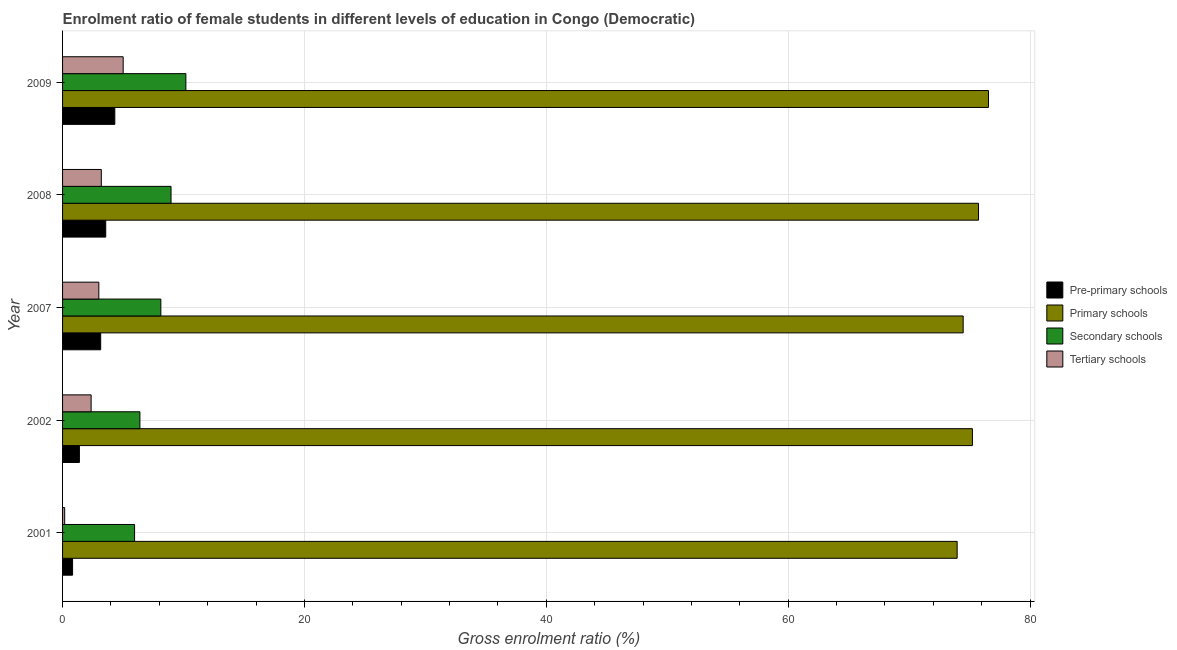How many different coloured bars are there?
Make the answer very short. 4. How many groups of bars are there?
Give a very brief answer. 5. How many bars are there on the 2nd tick from the bottom?
Provide a succinct answer. 4. What is the gross enrolment ratio(male) in pre-primary schools in 2002?
Your answer should be compact. 1.39. Across all years, what is the maximum gross enrolment ratio(male) in tertiary schools?
Ensure brevity in your answer.  5.01. Across all years, what is the minimum gross enrolment ratio(male) in tertiary schools?
Your answer should be very brief. 0.18. In which year was the gross enrolment ratio(male) in tertiary schools maximum?
Give a very brief answer. 2009. What is the total gross enrolment ratio(male) in secondary schools in the graph?
Make the answer very short. 39.64. What is the difference between the gross enrolment ratio(male) in secondary schools in 2002 and that in 2008?
Your answer should be very brief. -2.57. What is the difference between the gross enrolment ratio(male) in tertiary schools in 2002 and the gross enrolment ratio(male) in pre-primary schools in 2009?
Keep it short and to the point. -1.96. What is the average gross enrolment ratio(male) in pre-primary schools per year?
Provide a succinct answer. 2.65. In the year 2008, what is the difference between the gross enrolment ratio(male) in primary schools and gross enrolment ratio(male) in tertiary schools?
Offer a very short reply. 72.54. In how many years, is the gross enrolment ratio(male) in primary schools greater than 20 %?
Your response must be concise. 5. What is the ratio of the gross enrolment ratio(male) in secondary schools in 2008 to that in 2009?
Your answer should be very brief. 0.88. What is the difference between the highest and the second highest gross enrolment ratio(male) in pre-primary schools?
Your answer should be very brief. 0.75. What is the difference between the highest and the lowest gross enrolment ratio(male) in secondary schools?
Ensure brevity in your answer.  4.24. In how many years, is the gross enrolment ratio(male) in primary schools greater than the average gross enrolment ratio(male) in primary schools taken over all years?
Ensure brevity in your answer.  3. Is the sum of the gross enrolment ratio(male) in tertiary schools in 2001 and 2009 greater than the maximum gross enrolment ratio(male) in secondary schools across all years?
Offer a terse response. No. What does the 2nd bar from the top in 2007 represents?
Provide a succinct answer. Secondary schools. What does the 2nd bar from the bottom in 2007 represents?
Your answer should be compact. Primary schools. How many bars are there?
Offer a very short reply. 20. What is the difference between two consecutive major ticks on the X-axis?
Provide a succinct answer. 20. Does the graph contain grids?
Ensure brevity in your answer.  Yes. Where does the legend appear in the graph?
Provide a succinct answer. Center right. What is the title of the graph?
Give a very brief answer. Enrolment ratio of female students in different levels of education in Congo (Democratic). Does "HFC gas" appear as one of the legend labels in the graph?
Provide a succinct answer. No. What is the label or title of the X-axis?
Give a very brief answer. Gross enrolment ratio (%). What is the label or title of the Y-axis?
Your response must be concise. Year. What is the Gross enrolment ratio (%) of Pre-primary schools in 2001?
Keep it short and to the point. 0.83. What is the Gross enrolment ratio (%) of Primary schools in 2001?
Keep it short and to the point. 73.98. What is the Gross enrolment ratio (%) of Secondary schools in 2001?
Offer a very short reply. 5.95. What is the Gross enrolment ratio (%) in Tertiary schools in 2001?
Provide a short and direct response. 0.18. What is the Gross enrolment ratio (%) in Pre-primary schools in 2002?
Make the answer very short. 1.39. What is the Gross enrolment ratio (%) in Primary schools in 2002?
Offer a very short reply. 75.24. What is the Gross enrolment ratio (%) in Secondary schools in 2002?
Make the answer very short. 6.4. What is the Gross enrolment ratio (%) in Tertiary schools in 2002?
Provide a succinct answer. 2.36. What is the Gross enrolment ratio (%) of Pre-primary schools in 2007?
Your response must be concise. 3.15. What is the Gross enrolment ratio (%) of Primary schools in 2007?
Provide a succinct answer. 74.47. What is the Gross enrolment ratio (%) of Secondary schools in 2007?
Keep it short and to the point. 8.13. What is the Gross enrolment ratio (%) in Tertiary schools in 2007?
Ensure brevity in your answer.  3. What is the Gross enrolment ratio (%) of Pre-primary schools in 2008?
Provide a succinct answer. 3.57. What is the Gross enrolment ratio (%) in Primary schools in 2008?
Your response must be concise. 75.74. What is the Gross enrolment ratio (%) in Secondary schools in 2008?
Your response must be concise. 8.97. What is the Gross enrolment ratio (%) in Tertiary schools in 2008?
Give a very brief answer. 3.2. What is the Gross enrolment ratio (%) of Pre-primary schools in 2009?
Give a very brief answer. 4.32. What is the Gross enrolment ratio (%) in Primary schools in 2009?
Your response must be concise. 76.57. What is the Gross enrolment ratio (%) in Secondary schools in 2009?
Give a very brief answer. 10.2. What is the Gross enrolment ratio (%) of Tertiary schools in 2009?
Your answer should be compact. 5.01. Across all years, what is the maximum Gross enrolment ratio (%) of Pre-primary schools?
Keep it short and to the point. 4.32. Across all years, what is the maximum Gross enrolment ratio (%) in Primary schools?
Give a very brief answer. 76.57. Across all years, what is the maximum Gross enrolment ratio (%) of Secondary schools?
Your answer should be very brief. 10.2. Across all years, what is the maximum Gross enrolment ratio (%) of Tertiary schools?
Your answer should be very brief. 5.01. Across all years, what is the minimum Gross enrolment ratio (%) of Pre-primary schools?
Offer a very short reply. 0.83. Across all years, what is the minimum Gross enrolment ratio (%) of Primary schools?
Your answer should be very brief. 73.98. Across all years, what is the minimum Gross enrolment ratio (%) of Secondary schools?
Provide a short and direct response. 5.95. Across all years, what is the minimum Gross enrolment ratio (%) in Tertiary schools?
Offer a terse response. 0.18. What is the total Gross enrolment ratio (%) in Pre-primary schools in the graph?
Offer a very short reply. 13.26. What is the total Gross enrolment ratio (%) in Primary schools in the graph?
Offer a terse response. 376. What is the total Gross enrolment ratio (%) of Secondary schools in the graph?
Keep it short and to the point. 39.64. What is the total Gross enrolment ratio (%) in Tertiary schools in the graph?
Make the answer very short. 13.75. What is the difference between the Gross enrolment ratio (%) in Pre-primary schools in 2001 and that in 2002?
Offer a terse response. -0.56. What is the difference between the Gross enrolment ratio (%) in Primary schools in 2001 and that in 2002?
Ensure brevity in your answer.  -1.26. What is the difference between the Gross enrolment ratio (%) of Secondary schools in 2001 and that in 2002?
Your answer should be very brief. -0.44. What is the difference between the Gross enrolment ratio (%) of Tertiary schools in 2001 and that in 2002?
Ensure brevity in your answer.  -2.19. What is the difference between the Gross enrolment ratio (%) of Pre-primary schools in 2001 and that in 2007?
Provide a succinct answer. -2.32. What is the difference between the Gross enrolment ratio (%) of Primary schools in 2001 and that in 2007?
Ensure brevity in your answer.  -0.5. What is the difference between the Gross enrolment ratio (%) of Secondary schools in 2001 and that in 2007?
Ensure brevity in your answer.  -2.17. What is the difference between the Gross enrolment ratio (%) in Tertiary schools in 2001 and that in 2007?
Keep it short and to the point. -2.82. What is the difference between the Gross enrolment ratio (%) of Pre-primary schools in 2001 and that in 2008?
Your answer should be very brief. -2.74. What is the difference between the Gross enrolment ratio (%) in Primary schools in 2001 and that in 2008?
Provide a short and direct response. -1.77. What is the difference between the Gross enrolment ratio (%) in Secondary schools in 2001 and that in 2008?
Make the answer very short. -3.01. What is the difference between the Gross enrolment ratio (%) of Tertiary schools in 2001 and that in 2008?
Ensure brevity in your answer.  -3.03. What is the difference between the Gross enrolment ratio (%) in Pre-primary schools in 2001 and that in 2009?
Your answer should be compact. -3.49. What is the difference between the Gross enrolment ratio (%) in Primary schools in 2001 and that in 2009?
Keep it short and to the point. -2.59. What is the difference between the Gross enrolment ratio (%) in Secondary schools in 2001 and that in 2009?
Give a very brief answer. -4.24. What is the difference between the Gross enrolment ratio (%) in Tertiary schools in 2001 and that in 2009?
Your answer should be compact. -4.84. What is the difference between the Gross enrolment ratio (%) of Pre-primary schools in 2002 and that in 2007?
Your response must be concise. -1.76. What is the difference between the Gross enrolment ratio (%) in Primary schools in 2002 and that in 2007?
Ensure brevity in your answer.  0.76. What is the difference between the Gross enrolment ratio (%) of Secondary schools in 2002 and that in 2007?
Your response must be concise. -1.73. What is the difference between the Gross enrolment ratio (%) of Tertiary schools in 2002 and that in 2007?
Provide a short and direct response. -0.64. What is the difference between the Gross enrolment ratio (%) of Pre-primary schools in 2002 and that in 2008?
Provide a succinct answer. -2.18. What is the difference between the Gross enrolment ratio (%) of Primary schools in 2002 and that in 2008?
Provide a short and direct response. -0.5. What is the difference between the Gross enrolment ratio (%) in Secondary schools in 2002 and that in 2008?
Offer a terse response. -2.57. What is the difference between the Gross enrolment ratio (%) of Tertiary schools in 2002 and that in 2008?
Provide a succinct answer. -0.84. What is the difference between the Gross enrolment ratio (%) of Pre-primary schools in 2002 and that in 2009?
Make the answer very short. -2.93. What is the difference between the Gross enrolment ratio (%) in Primary schools in 2002 and that in 2009?
Offer a very short reply. -1.33. What is the difference between the Gross enrolment ratio (%) of Secondary schools in 2002 and that in 2009?
Ensure brevity in your answer.  -3.8. What is the difference between the Gross enrolment ratio (%) of Tertiary schools in 2002 and that in 2009?
Your response must be concise. -2.65. What is the difference between the Gross enrolment ratio (%) in Pre-primary schools in 2007 and that in 2008?
Your response must be concise. -0.42. What is the difference between the Gross enrolment ratio (%) in Primary schools in 2007 and that in 2008?
Your response must be concise. -1.27. What is the difference between the Gross enrolment ratio (%) in Secondary schools in 2007 and that in 2008?
Make the answer very short. -0.84. What is the difference between the Gross enrolment ratio (%) of Tertiary schools in 2007 and that in 2008?
Give a very brief answer. -0.21. What is the difference between the Gross enrolment ratio (%) in Pre-primary schools in 2007 and that in 2009?
Provide a succinct answer. -1.17. What is the difference between the Gross enrolment ratio (%) in Primary schools in 2007 and that in 2009?
Provide a succinct answer. -2.09. What is the difference between the Gross enrolment ratio (%) of Secondary schools in 2007 and that in 2009?
Ensure brevity in your answer.  -2.07. What is the difference between the Gross enrolment ratio (%) of Tertiary schools in 2007 and that in 2009?
Your response must be concise. -2.01. What is the difference between the Gross enrolment ratio (%) in Pre-primary schools in 2008 and that in 2009?
Your answer should be very brief. -0.75. What is the difference between the Gross enrolment ratio (%) of Primary schools in 2008 and that in 2009?
Your answer should be compact. -0.83. What is the difference between the Gross enrolment ratio (%) of Secondary schools in 2008 and that in 2009?
Your answer should be compact. -1.23. What is the difference between the Gross enrolment ratio (%) in Tertiary schools in 2008 and that in 2009?
Provide a short and direct response. -1.81. What is the difference between the Gross enrolment ratio (%) of Pre-primary schools in 2001 and the Gross enrolment ratio (%) of Primary schools in 2002?
Make the answer very short. -74.41. What is the difference between the Gross enrolment ratio (%) of Pre-primary schools in 2001 and the Gross enrolment ratio (%) of Secondary schools in 2002?
Keep it short and to the point. -5.57. What is the difference between the Gross enrolment ratio (%) of Pre-primary schools in 2001 and the Gross enrolment ratio (%) of Tertiary schools in 2002?
Offer a terse response. -1.53. What is the difference between the Gross enrolment ratio (%) in Primary schools in 2001 and the Gross enrolment ratio (%) in Secondary schools in 2002?
Offer a very short reply. 67.58. What is the difference between the Gross enrolment ratio (%) of Primary schools in 2001 and the Gross enrolment ratio (%) of Tertiary schools in 2002?
Your answer should be very brief. 71.61. What is the difference between the Gross enrolment ratio (%) in Secondary schools in 2001 and the Gross enrolment ratio (%) in Tertiary schools in 2002?
Make the answer very short. 3.59. What is the difference between the Gross enrolment ratio (%) in Pre-primary schools in 2001 and the Gross enrolment ratio (%) in Primary schools in 2007?
Provide a succinct answer. -73.65. What is the difference between the Gross enrolment ratio (%) of Pre-primary schools in 2001 and the Gross enrolment ratio (%) of Secondary schools in 2007?
Keep it short and to the point. -7.3. What is the difference between the Gross enrolment ratio (%) in Pre-primary schools in 2001 and the Gross enrolment ratio (%) in Tertiary schools in 2007?
Offer a very short reply. -2.17. What is the difference between the Gross enrolment ratio (%) of Primary schools in 2001 and the Gross enrolment ratio (%) of Secondary schools in 2007?
Ensure brevity in your answer.  65.85. What is the difference between the Gross enrolment ratio (%) of Primary schools in 2001 and the Gross enrolment ratio (%) of Tertiary schools in 2007?
Provide a short and direct response. 70.98. What is the difference between the Gross enrolment ratio (%) in Secondary schools in 2001 and the Gross enrolment ratio (%) in Tertiary schools in 2007?
Make the answer very short. 2.96. What is the difference between the Gross enrolment ratio (%) of Pre-primary schools in 2001 and the Gross enrolment ratio (%) of Primary schools in 2008?
Your answer should be very brief. -74.91. What is the difference between the Gross enrolment ratio (%) in Pre-primary schools in 2001 and the Gross enrolment ratio (%) in Secondary schools in 2008?
Your answer should be compact. -8.14. What is the difference between the Gross enrolment ratio (%) in Pre-primary schools in 2001 and the Gross enrolment ratio (%) in Tertiary schools in 2008?
Offer a terse response. -2.38. What is the difference between the Gross enrolment ratio (%) of Primary schools in 2001 and the Gross enrolment ratio (%) of Secondary schools in 2008?
Your answer should be very brief. 65.01. What is the difference between the Gross enrolment ratio (%) in Primary schools in 2001 and the Gross enrolment ratio (%) in Tertiary schools in 2008?
Your answer should be compact. 70.77. What is the difference between the Gross enrolment ratio (%) in Secondary schools in 2001 and the Gross enrolment ratio (%) in Tertiary schools in 2008?
Keep it short and to the point. 2.75. What is the difference between the Gross enrolment ratio (%) of Pre-primary schools in 2001 and the Gross enrolment ratio (%) of Primary schools in 2009?
Make the answer very short. -75.74. What is the difference between the Gross enrolment ratio (%) of Pre-primary schools in 2001 and the Gross enrolment ratio (%) of Secondary schools in 2009?
Your answer should be compact. -9.37. What is the difference between the Gross enrolment ratio (%) in Pre-primary schools in 2001 and the Gross enrolment ratio (%) in Tertiary schools in 2009?
Provide a succinct answer. -4.18. What is the difference between the Gross enrolment ratio (%) in Primary schools in 2001 and the Gross enrolment ratio (%) in Secondary schools in 2009?
Provide a succinct answer. 63.78. What is the difference between the Gross enrolment ratio (%) in Primary schools in 2001 and the Gross enrolment ratio (%) in Tertiary schools in 2009?
Ensure brevity in your answer.  68.96. What is the difference between the Gross enrolment ratio (%) of Secondary schools in 2001 and the Gross enrolment ratio (%) of Tertiary schools in 2009?
Provide a short and direct response. 0.94. What is the difference between the Gross enrolment ratio (%) of Pre-primary schools in 2002 and the Gross enrolment ratio (%) of Primary schools in 2007?
Ensure brevity in your answer.  -73.08. What is the difference between the Gross enrolment ratio (%) in Pre-primary schools in 2002 and the Gross enrolment ratio (%) in Secondary schools in 2007?
Keep it short and to the point. -6.73. What is the difference between the Gross enrolment ratio (%) of Pre-primary schools in 2002 and the Gross enrolment ratio (%) of Tertiary schools in 2007?
Your answer should be very brief. -1.61. What is the difference between the Gross enrolment ratio (%) in Primary schools in 2002 and the Gross enrolment ratio (%) in Secondary schools in 2007?
Offer a very short reply. 67.11. What is the difference between the Gross enrolment ratio (%) of Primary schools in 2002 and the Gross enrolment ratio (%) of Tertiary schools in 2007?
Provide a short and direct response. 72.24. What is the difference between the Gross enrolment ratio (%) in Secondary schools in 2002 and the Gross enrolment ratio (%) in Tertiary schools in 2007?
Keep it short and to the point. 3.4. What is the difference between the Gross enrolment ratio (%) in Pre-primary schools in 2002 and the Gross enrolment ratio (%) in Primary schools in 2008?
Give a very brief answer. -74.35. What is the difference between the Gross enrolment ratio (%) of Pre-primary schools in 2002 and the Gross enrolment ratio (%) of Secondary schools in 2008?
Offer a terse response. -7.58. What is the difference between the Gross enrolment ratio (%) in Pre-primary schools in 2002 and the Gross enrolment ratio (%) in Tertiary schools in 2008?
Offer a terse response. -1.81. What is the difference between the Gross enrolment ratio (%) of Primary schools in 2002 and the Gross enrolment ratio (%) of Secondary schools in 2008?
Offer a very short reply. 66.27. What is the difference between the Gross enrolment ratio (%) in Primary schools in 2002 and the Gross enrolment ratio (%) in Tertiary schools in 2008?
Ensure brevity in your answer.  72.03. What is the difference between the Gross enrolment ratio (%) in Secondary schools in 2002 and the Gross enrolment ratio (%) in Tertiary schools in 2008?
Give a very brief answer. 3.19. What is the difference between the Gross enrolment ratio (%) in Pre-primary schools in 2002 and the Gross enrolment ratio (%) in Primary schools in 2009?
Make the answer very short. -75.18. What is the difference between the Gross enrolment ratio (%) in Pre-primary schools in 2002 and the Gross enrolment ratio (%) in Secondary schools in 2009?
Provide a succinct answer. -8.8. What is the difference between the Gross enrolment ratio (%) in Pre-primary schools in 2002 and the Gross enrolment ratio (%) in Tertiary schools in 2009?
Make the answer very short. -3.62. What is the difference between the Gross enrolment ratio (%) in Primary schools in 2002 and the Gross enrolment ratio (%) in Secondary schools in 2009?
Keep it short and to the point. 65.04. What is the difference between the Gross enrolment ratio (%) in Primary schools in 2002 and the Gross enrolment ratio (%) in Tertiary schools in 2009?
Your answer should be compact. 70.23. What is the difference between the Gross enrolment ratio (%) in Secondary schools in 2002 and the Gross enrolment ratio (%) in Tertiary schools in 2009?
Your response must be concise. 1.38. What is the difference between the Gross enrolment ratio (%) of Pre-primary schools in 2007 and the Gross enrolment ratio (%) of Primary schools in 2008?
Provide a succinct answer. -72.59. What is the difference between the Gross enrolment ratio (%) of Pre-primary schools in 2007 and the Gross enrolment ratio (%) of Secondary schools in 2008?
Make the answer very short. -5.82. What is the difference between the Gross enrolment ratio (%) of Pre-primary schools in 2007 and the Gross enrolment ratio (%) of Tertiary schools in 2008?
Keep it short and to the point. -0.05. What is the difference between the Gross enrolment ratio (%) in Primary schools in 2007 and the Gross enrolment ratio (%) in Secondary schools in 2008?
Offer a very short reply. 65.5. What is the difference between the Gross enrolment ratio (%) of Primary schools in 2007 and the Gross enrolment ratio (%) of Tertiary schools in 2008?
Offer a terse response. 71.27. What is the difference between the Gross enrolment ratio (%) of Secondary schools in 2007 and the Gross enrolment ratio (%) of Tertiary schools in 2008?
Give a very brief answer. 4.92. What is the difference between the Gross enrolment ratio (%) of Pre-primary schools in 2007 and the Gross enrolment ratio (%) of Primary schools in 2009?
Your answer should be compact. -73.42. What is the difference between the Gross enrolment ratio (%) in Pre-primary schools in 2007 and the Gross enrolment ratio (%) in Secondary schools in 2009?
Provide a succinct answer. -7.04. What is the difference between the Gross enrolment ratio (%) in Pre-primary schools in 2007 and the Gross enrolment ratio (%) in Tertiary schools in 2009?
Your response must be concise. -1.86. What is the difference between the Gross enrolment ratio (%) of Primary schools in 2007 and the Gross enrolment ratio (%) of Secondary schools in 2009?
Make the answer very short. 64.28. What is the difference between the Gross enrolment ratio (%) in Primary schools in 2007 and the Gross enrolment ratio (%) in Tertiary schools in 2009?
Your response must be concise. 69.46. What is the difference between the Gross enrolment ratio (%) of Secondary schools in 2007 and the Gross enrolment ratio (%) of Tertiary schools in 2009?
Make the answer very short. 3.12. What is the difference between the Gross enrolment ratio (%) of Pre-primary schools in 2008 and the Gross enrolment ratio (%) of Primary schools in 2009?
Your answer should be very brief. -73. What is the difference between the Gross enrolment ratio (%) of Pre-primary schools in 2008 and the Gross enrolment ratio (%) of Secondary schools in 2009?
Your answer should be very brief. -6.63. What is the difference between the Gross enrolment ratio (%) of Pre-primary schools in 2008 and the Gross enrolment ratio (%) of Tertiary schools in 2009?
Ensure brevity in your answer.  -1.44. What is the difference between the Gross enrolment ratio (%) in Primary schools in 2008 and the Gross enrolment ratio (%) in Secondary schools in 2009?
Give a very brief answer. 65.54. What is the difference between the Gross enrolment ratio (%) in Primary schools in 2008 and the Gross enrolment ratio (%) in Tertiary schools in 2009?
Keep it short and to the point. 70.73. What is the difference between the Gross enrolment ratio (%) of Secondary schools in 2008 and the Gross enrolment ratio (%) of Tertiary schools in 2009?
Ensure brevity in your answer.  3.96. What is the average Gross enrolment ratio (%) in Pre-primary schools per year?
Offer a terse response. 2.65. What is the average Gross enrolment ratio (%) of Primary schools per year?
Your answer should be compact. 75.2. What is the average Gross enrolment ratio (%) in Secondary schools per year?
Provide a short and direct response. 7.93. What is the average Gross enrolment ratio (%) of Tertiary schools per year?
Offer a very short reply. 2.75. In the year 2001, what is the difference between the Gross enrolment ratio (%) in Pre-primary schools and Gross enrolment ratio (%) in Primary schools?
Your answer should be very brief. -73.15. In the year 2001, what is the difference between the Gross enrolment ratio (%) of Pre-primary schools and Gross enrolment ratio (%) of Secondary schools?
Offer a very short reply. -5.13. In the year 2001, what is the difference between the Gross enrolment ratio (%) of Pre-primary schools and Gross enrolment ratio (%) of Tertiary schools?
Your response must be concise. 0.65. In the year 2001, what is the difference between the Gross enrolment ratio (%) in Primary schools and Gross enrolment ratio (%) in Secondary schools?
Your answer should be compact. 68.02. In the year 2001, what is the difference between the Gross enrolment ratio (%) of Primary schools and Gross enrolment ratio (%) of Tertiary schools?
Give a very brief answer. 73.8. In the year 2001, what is the difference between the Gross enrolment ratio (%) in Secondary schools and Gross enrolment ratio (%) in Tertiary schools?
Ensure brevity in your answer.  5.78. In the year 2002, what is the difference between the Gross enrolment ratio (%) of Pre-primary schools and Gross enrolment ratio (%) of Primary schools?
Provide a short and direct response. -73.85. In the year 2002, what is the difference between the Gross enrolment ratio (%) in Pre-primary schools and Gross enrolment ratio (%) in Secondary schools?
Keep it short and to the point. -5. In the year 2002, what is the difference between the Gross enrolment ratio (%) in Pre-primary schools and Gross enrolment ratio (%) in Tertiary schools?
Provide a succinct answer. -0.97. In the year 2002, what is the difference between the Gross enrolment ratio (%) in Primary schools and Gross enrolment ratio (%) in Secondary schools?
Your answer should be very brief. 68.84. In the year 2002, what is the difference between the Gross enrolment ratio (%) in Primary schools and Gross enrolment ratio (%) in Tertiary schools?
Offer a terse response. 72.88. In the year 2002, what is the difference between the Gross enrolment ratio (%) in Secondary schools and Gross enrolment ratio (%) in Tertiary schools?
Ensure brevity in your answer.  4.03. In the year 2007, what is the difference between the Gross enrolment ratio (%) in Pre-primary schools and Gross enrolment ratio (%) in Primary schools?
Offer a very short reply. -71.32. In the year 2007, what is the difference between the Gross enrolment ratio (%) in Pre-primary schools and Gross enrolment ratio (%) in Secondary schools?
Give a very brief answer. -4.97. In the year 2007, what is the difference between the Gross enrolment ratio (%) of Pre-primary schools and Gross enrolment ratio (%) of Tertiary schools?
Make the answer very short. 0.15. In the year 2007, what is the difference between the Gross enrolment ratio (%) in Primary schools and Gross enrolment ratio (%) in Secondary schools?
Make the answer very short. 66.35. In the year 2007, what is the difference between the Gross enrolment ratio (%) of Primary schools and Gross enrolment ratio (%) of Tertiary schools?
Give a very brief answer. 71.48. In the year 2007, what is the difference between the Gross enrolment ratio (%) of Secondary schools and Gross enrolment ratio (%) of Tertiary schools?
Provide a succinct answer. 5.13. In the year 2008, what is the difference between the Gross enrolment ratio (%) in Pre-primary schools and Gross enrolment ratio (%) in Primary schools?
Ensure brevity in your answer.  -72.17. In the year 2008, what is the difference between the Gross enrolment ratio (%) in Pre-primary schools and Gross enrolment ratio (%) in Secondary schools?
Your answer should be compact. -5.4. In the year 2008, what is the difference between the Gross enrolment ratio (%) in Pre-primary schools and Gross enrolment ratio (%) in Tertiary schools?
Offer a terse response. 0.37. In the year 2008, what is the difference between the Gross enrolment ratio (%) of Primary schools and Gross enrolment ratio (%) of Secondary schools?
Ensure brevity in your answer.  66.77. In the year 2008, what is the difference between the Gross enrolment ratio (%) of Primary schools and Gross enrolment ratio (%) of Tertiary schools?
Ensure brevity in your answer.  72.54. In the year 2008, what is the difference between the Gross enrolment ratio (%) of Secondary schools and Gross enrolment ratio (%) of Tertiary schools?
Keep it short and to the point. 5.77. In the year 2009, what is the difference between the Gross enrolment ratio (%) in Pre-primary schools and Gross enrolment ratio (%) in Primary schools?
Give a very brief answer. -72.25. In the year 2009, what is the difference between the Gross enrolment ratio (%) of Pre-primary schools and Gross enrolment ratio (%) of Secondary schools?
Keep it short and to the point. -5.88. In the year 2009, what is the difference between the Gross enrolment ratio (%) of Pre-primary schools and Gross enrolment ratio (%) of Tertiary schools?
Offer a very short reply. -0.69. In the year 2009, what is the difference between the Gross enrolment ratio (%) of Primary schools and Gross enrolment ratio (%) of Secondary schools?
Offer a terse response. 66.37. In the year 2009, what is the difference between the Gross enrolment ratio (%) in Primary schools and Gross enrolment ratio (%) in Tertiary schools?
Give a very brief answer. 71.56. In the year 2009, what is the difference between the Gross enrolment ratio (%) in Secondary schools and Gross enrolment ratio (%) in Tertiary schools?
Provide a short and direct response. 5.19. What is the ratio of the Gross enrolment ratio (%) in Pre-primary schools in 2001 to that in 2002?
Provide a succinct answer. 0.59. What is the ratio of the Gross enrolment ratio (%) in Primary schools in 2001 to that in 2002?
Offer a terse response. 0.98. What is the ratio of the Gross enrolment ratio (%) in Secondary schools in 2001 to that in 2002?
Your answer should be compact. 0.93. What is the ratio of the Gross enrolment ratio (%) of Tertiary schools in 2001 to that in 2002?
Ensure brevity in your answer.  0.07. What is the ratio of the Gross enrolment ratio (%) in Pre-primary schools in 2001 to that in 2007?
Provide a short and direct response. 0.26. What is the ratio of the Gross enrolment ratio (%) in Secondary schools in 2001 to that in 2007?
Offer a terse response. 0.73. What is the ratio of the Gross enrolment ratio (%) in Tertiary schools in 2001 to that in 2007?
Offer a terse response. 0.06. What is the ratio of the Gross enrolment ratio (%) of Pre-primary schools in 2001 to that in 2008?
Provide a short and direct response. 0.23. What is the ratio of the Gross enrolment ratio (%) in Primary schools in 2001 to that in 2008?
Provide a succinct answer. 0.98. What is the ratio of the Gross enrolment ratio (%) of Secondary schools in 2001 to that in 2008?
Your answer should be compact. 0.66. What is the ratio of the Gross enrolment ratio (%) in Tertiary schools in 2001 to that in 2008?
Offer a terse response. 0.05. What is the ratio of the Gross enrolment ratio (%) in Pre-primary schools in 2001 to that in 2009?
Provide a succinct answer. 0.19. What is the ratio of the Gross enrolment ratio (%) in Primary schools in 2001 to that in 2009?
Provide a short and direct response. 0.97. What is the ratio of the Gross enrolment ratio (%) of Secondary schools in 2001 to that in 2009?
Provide a short and direct response. 0.58. What is the ratio of the Gross enrolment ratio (%) of Tertiary schools in 2001 to that in 2009?
Make the answer very short. 0.04. What is the ratio of the Gross enrolment ratio (%) in Pre-primary schools in 2002 to that in 2007?
Your answer should be compact. 0.44. What is the ratio of the Gross enrolment ratio (%) of Primary schools in 2002 to that in 2007?
Offer a very short reply. 1.01. What is the ratio of the Gross enrolment ratio (%) in Secondary schools in 2002 to that in 2007?
Ensure brevity in your answer.  0.79. What is the ratio of the Gross enrolment ratio (%) of Tertiary schools in 2002 to that in 2007?
Your answer should be very brief. 0.79. What is the ratio of the Gross enrolment ratio (%) of Pre-primary schools in 2002 to that in 2008?
Offer a terse response. 0.39. What is the ratio of the Gross enrolment ratio (%) of Secondary schools in 2002 to that in 2008?
Ensure brevity in your answer.  0.71. What is the ratio of the Gross enrolment ratio (%) of Tertiary schools in 2002 to that in 2008?
Your response must be concise. 0.74. What is the ratio of the Gross enrolment ratio (%) of Pre-primary schools in 2002 to that in 2009?
Keep it short and to the point. 0.32. What is the ratio of the Gross enrolment ratio (%) in Primary schools in 2002 to that in 2009?
Offer a very short reply. 0.98. What is the ratio of the Gross enrolment ratio (%) in Secondary schools in 2002 to that in 2009?
Provide a short and direct response. 0.63. What is the ratio of the Gross enrolment ratio (%) in Tertiary schools in 2002 to that in 2009?
Make the answer very short. 0.47. What is the ratio of the Gross enrolment ratio (%) in Pre-primary schools in 2007 to that in 2008?
Make the answer very short. 0.88. What is the ratio of the Gross enrolment ratio (%) of Primary schools in 2007 to that in 2008?
Ensure brevity in your answer.  0.98. What is the ratio of the Gross enrolment ratio (%) in Secondary schools in 2007 to that in 2008?
Give a very brief answer. 0.91. What is the ratio of the Gross enrolment ratio (%) in Tertiary schools in 2007 to that in 2008?
Your response must be concise. 0.94. What is the ratio of the Gross enrolment ratio (%) in Pre-primary schools in 2007 to that in 2009?
Provide a short and direct response. 0.73. What is the ratio of the Gross enrolment ratio (%) of Primary schools in 2007 to that in 2009?
Provide a succinct answer. 0.97. What is the ratio of the Gross enrolment ratio (%) of Secondary schools in 2007 to that in 2009?
Provide a short and direct response. 0.8. What is the ratio of the Gross enrolment ratio (%) in Tertiary schools in 2007 to that in 2009?
Ensure brevity in your answer.  0.6. What is the ratio of the Gross enrolment ratio (%) in Pre-primary schools in 2008 to that in 2009?
Give a very brief answer. 0.83. What is the ratio of the Gross enrolment ratio (%) in Secondary schools in 2008 to that in 2009?
Ensure brevity in your answer.  0.88. What is the ratio of the Gross enrolment ratio (%) in Tertiary schools in 2008 to that in 2009?
Provide a short and direct response. 0.64. What is the difference between the highest and the second highest Gross enrolment ratio (%) of Pre-primary schools?
Keep it short and to the point. 0.75. What is the difference between the highest and the second highest Gross enrolment ratio (%) of Primary schools?
Offer a terse response. 0.83. What is the difference between the highest and the second highest Gross enrolment ratio (%) in Secondary schools?
Your response must be concise. 1.23. What is the difference between the highest and the second highest Gross enrolment ratio (%) of Tertiary schools?
Give a very brief answer. 1.81. What is the difference between the highest and the lowest Gross enrolment ratio (%) of Pre-primary schools?
Your answer should be very brief. 3.49. What is the difference between the highest and the lowest Gross enrolment ratio (%) of Primary schools?
Make the answer very short. 2.59. What is the difference between the highest and the lowest Gross enrolment ratio (%) of Secondary schools?
Provide a short and direct response. 4.24. What is the difference between the highest and the lowest Gross enrolment ratio (%) of Tertiary schools?
Your answer should be compact. 4.84. 